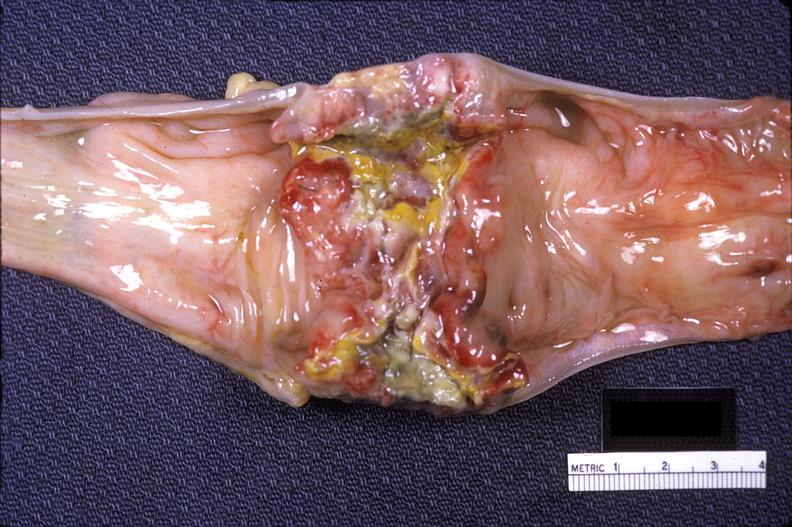where does this belong to?
Answer the question using a single word or phrase. Gastrointestinal system 